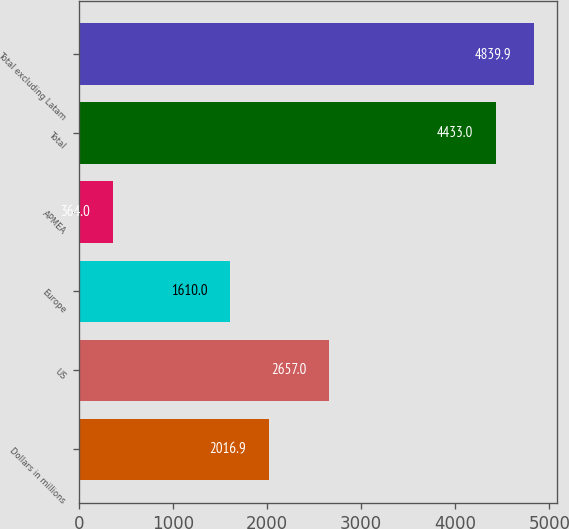<chart> <loc_0><loc_0><loc_500><loc_500><bar_chart><fcel>Dollars in millions<fcel>US<fcel>Europe<fcel>APMEA<fcel>Total<fcel>Total excluding Latam<nl><fcel>2016.9<fcel>2657<fcel>1610<fcel>364<fcel>4433<fcel>4839.9<nl></chart> 